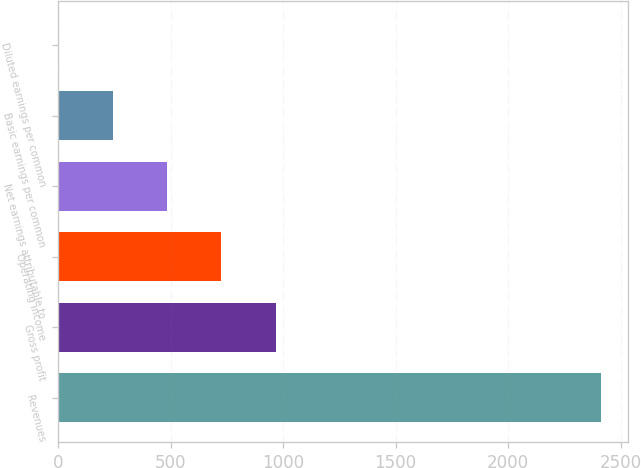Convert chart to OTSL. <chart><loc_0><loc_0><loc_500><loc_500><bar_chart><fcel>Revenues<fcel>Gross profit<fcel>Operating income<fcel>Net earnings attributable to<fcel>Basic earnings per common<fcel>Diluted earnings per common<nl><fcel>2413.7<fcel>966.53<fcel>725.33<fcel>484.13<fcel>242.94<fcel>1.75<nl></chart> 